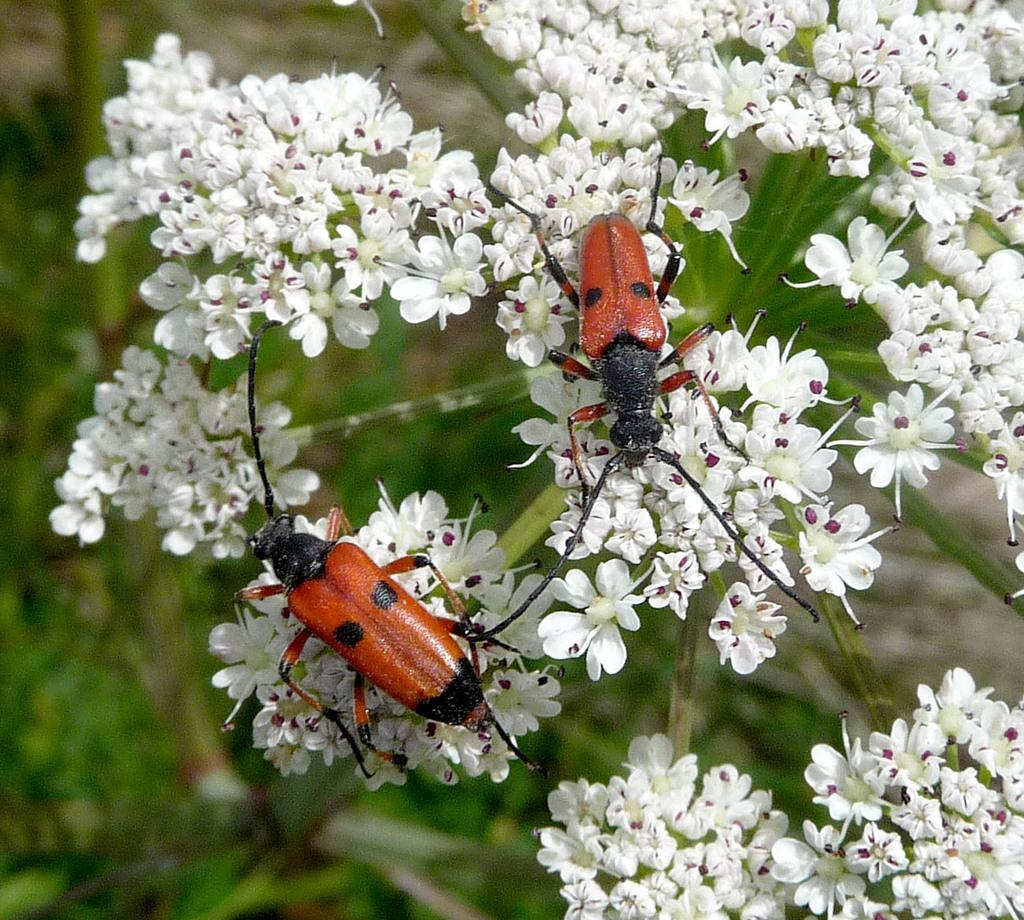What type of flowers can be seen in the image? There are white color flowers in the image. Are there any other living organisms present on the flowers? Yes, there are two insects on the flowers. What can be seen in the background of the image? There is a plant in the background of the image. How would you describe the appearance of the background? The background appears blurry. What type of journey is the girl embarking on in the image? There is no girl present in the image, so it is not possible to discuss her journey. 